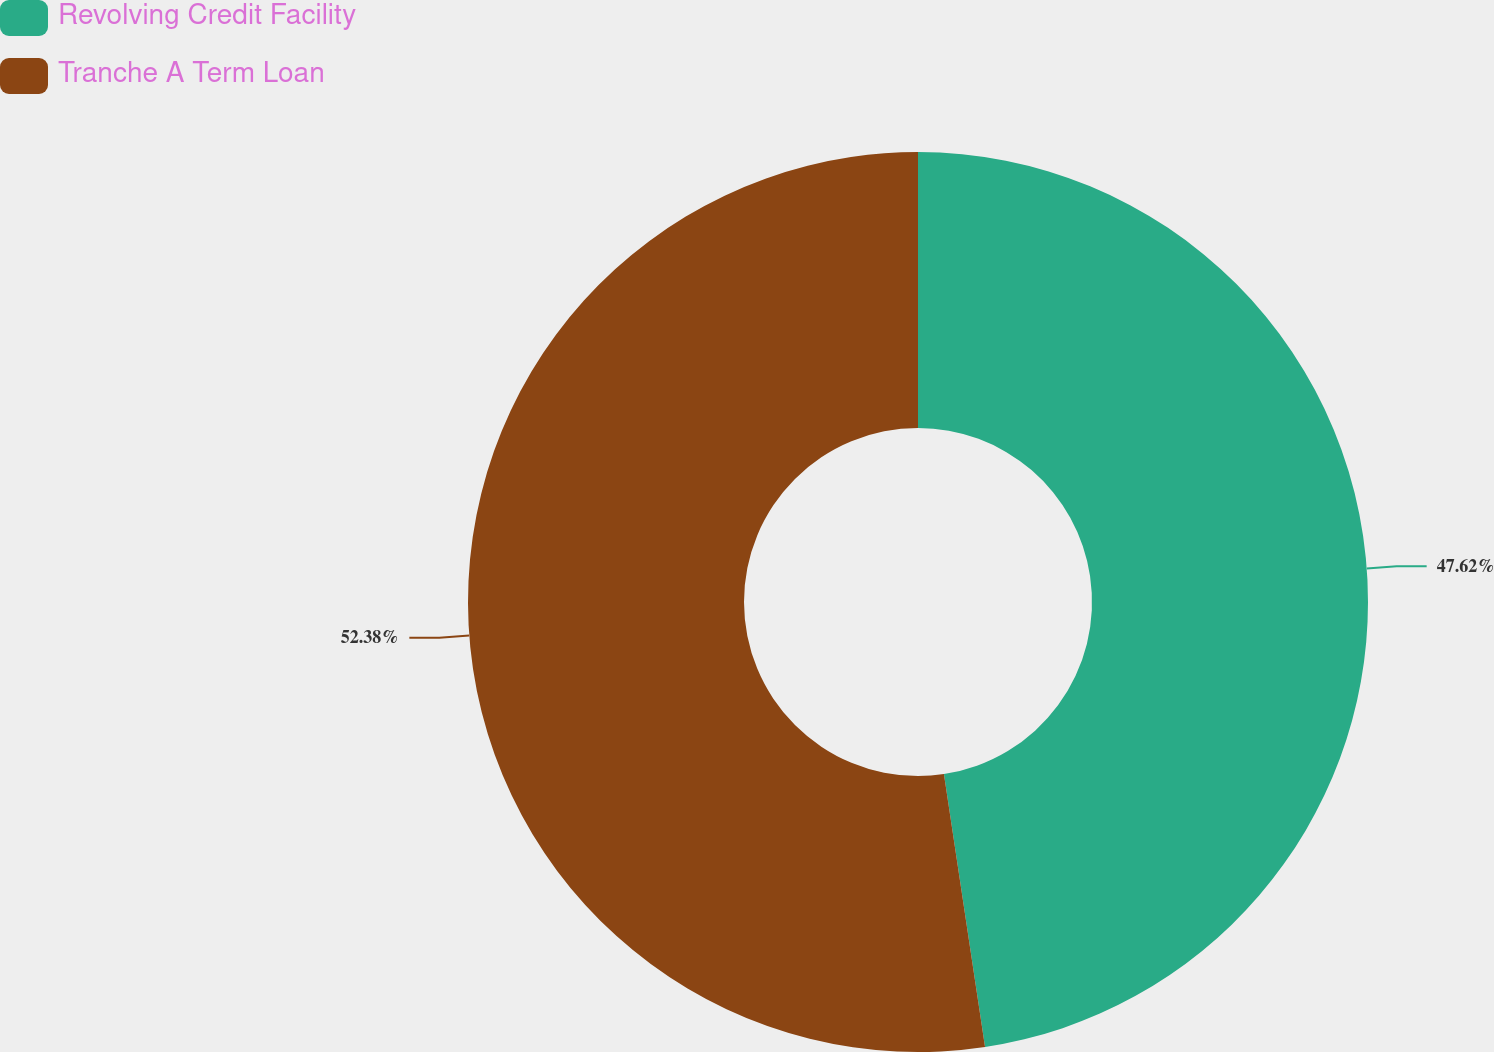Convert chart. <chart><loc_0><loc_0><loc_500><loc_500><pie_chart><fcel>Revolving Credit Facility<fcel>Tranche A Term Loan<nl><fcel>47.62%<fcel>52.38%<nl></chart> 